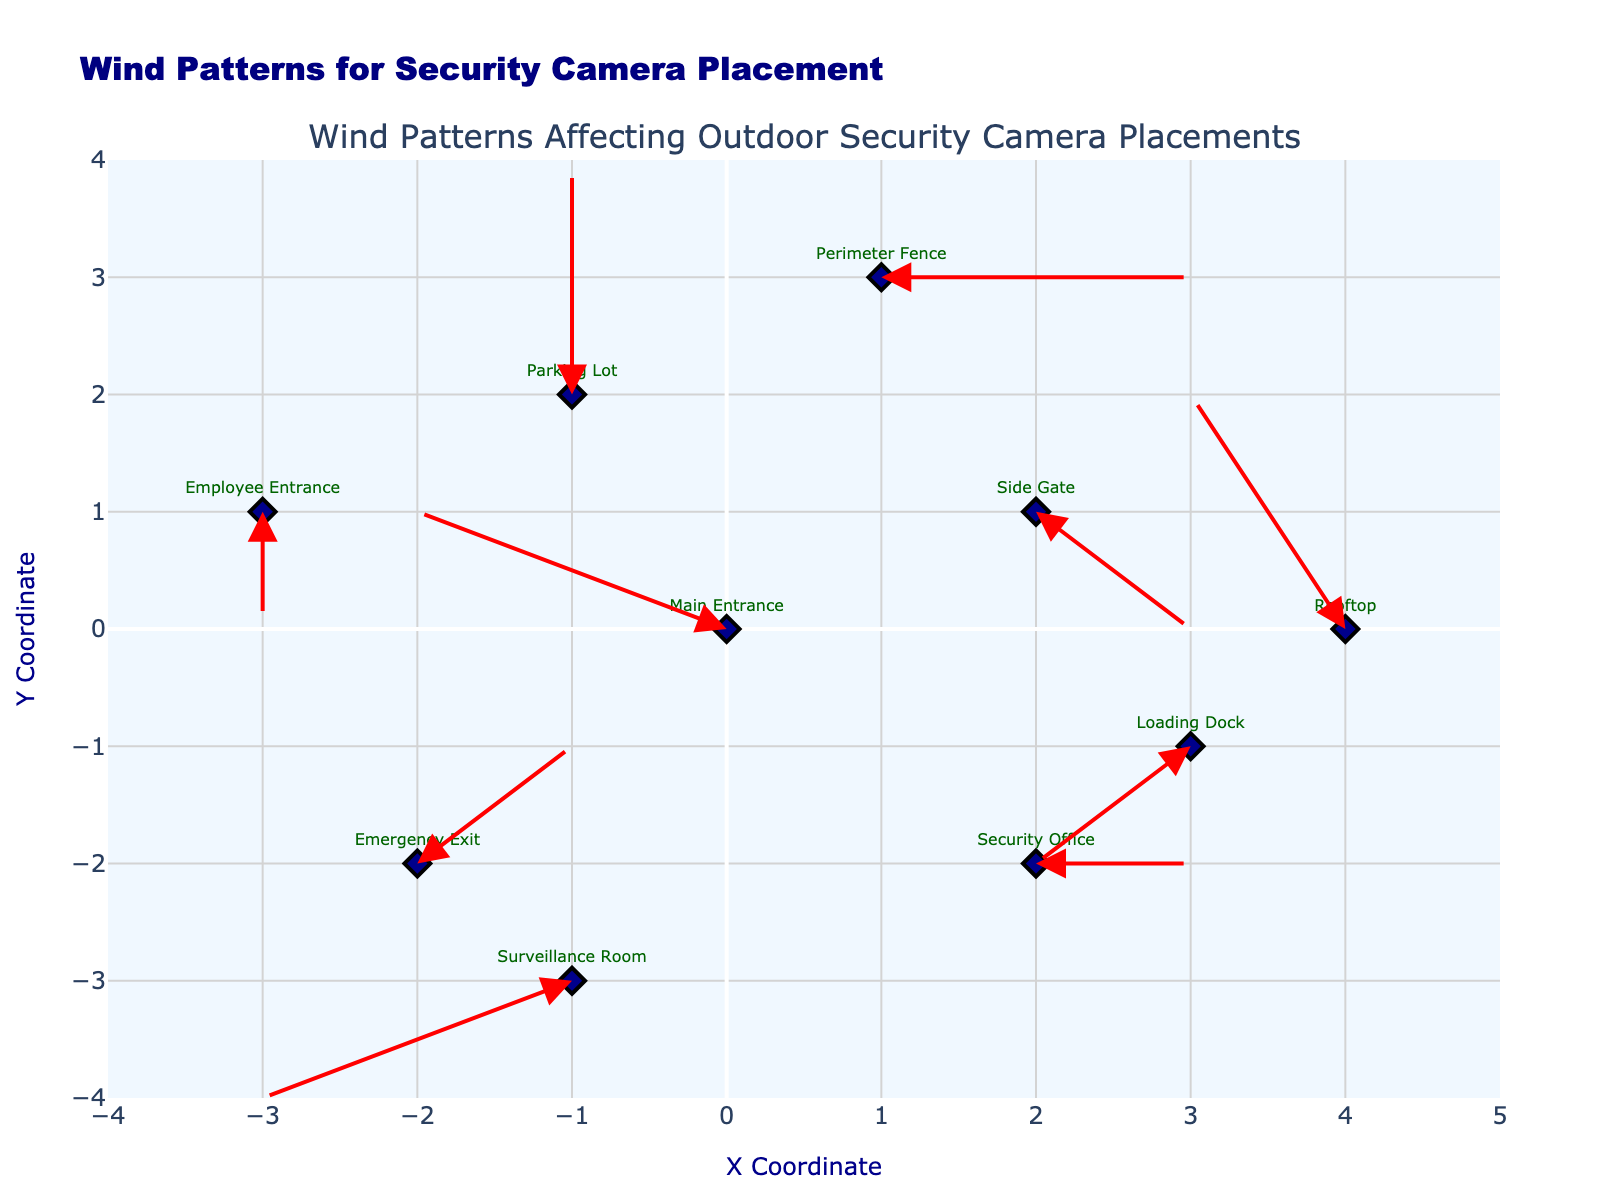What is the title of the plot? The title of the plot is located at the top of the figure and reads "Wind Patterns for Security Camera Placement".
Answer: Wind Patterns for Security Camera Placement How many different locations are plotted in the figure? There are 10 data points in the plot, each labeled with a different location, including Main Entrance, Side Gate, Parking Lot, Loading Dock, Perimeter Fence, Emergency Exit, Rooftop, Employee Entrance, Security Office, and Surveillance Room.
Answer: 10 What is the color of the markers representing the locations? The markers representing the locations are colored dark blue in the plot.
Answer: Dark blue Which location has the wind vector pointing directly downward? Observing the arrows in the plot, the Employee Entrance located at (-3, 1) has a wind vector pointing directly downward because its v component is -1 and its u component is 0.
Answer: Employee Entrance What are the coordinates of the Emergency Exit? To find the coordinates of the Emergency Exit, locate the marker labeled "Emergency Exit" in the plot. The coordinates are (-2, -2).
Answer: (-2, -2) Which locations have a wind vector with no horizontal component (u = 0)? Identifying the wind vectors without a horizontal component, we find that the Parking Lot and Employee Entrance both have u = 0.
Answer: Parking Lot, Employee Entrance What is the length of the wind vector at the Rooftop? The wind vector length can be calculated using the Pythagorean theorem: \(\sqrt{(-1)^2 + 2^2} = \sqrt{1 + 4} = \sqrt{5} \approx 2.24\).
Answer: ~2.24 Which location has the longest total wind vector? The total wind vector length can be calculated for each location, but the marker with the highest magnitude of vectors is clearly seen at the Main Entrance with vector components (-2, 1). The magnitude is calculated as: \(\sqrt{(-2)^2 + 1^2} = \sqrt{4 + 1} = \sqrt{5} \approx 2.24\).
Answer: Main Entrance Which location has the largest upward wind vector component (v > 0)? Observing the plot, the Parking Lot at coordinates (-1, 2) has the largest upward wind component with v = 2.
Answer: Parking Lot Do any locations have a wind vector with only a horizontal component and no vertical component (v = 0)? Analyzing the arrows, we see that Perimeter Fence and Security Office have wind vectors with only a horizontal component since v = 0 for both.
Answer: Perimeter Fence, Security Office 